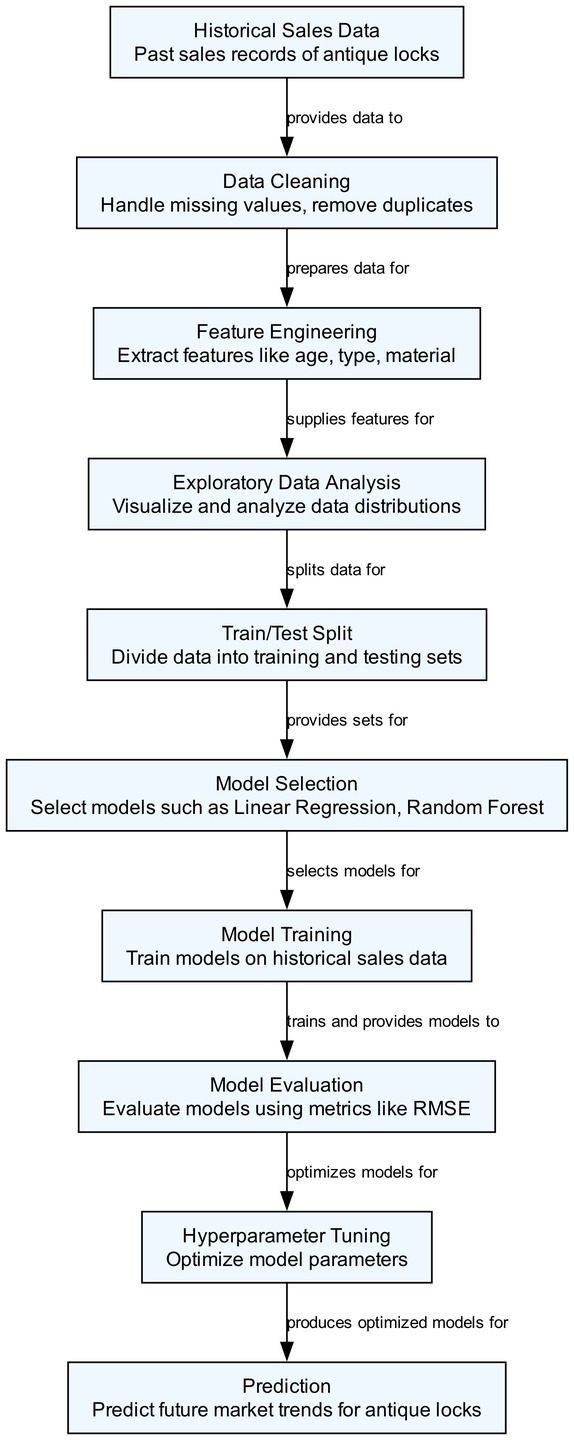What is the total number of nodes in the diagram? The diagram contains 10 nodes, which can be counted by listing each node represented in the diagram from the data provided.
Answer: 10 What does the node labeled "Historical Sales Data" provide data to? The "Historical Sales Data" node provides data to the "Data Cleaning" node, as indicated by the directed edge connecting them in the diagram.
Answer: Data Cleaning What follows after "Model Evaluation" in the process? After "Model Evaluation," the next step is "Hyperparameter Tuning," which is shown as a directed connection from the evaluation to the tuning in the diagram.
Answer: Hyperparameter Tuning Which node is responsible for extracting features? The node responsible for extracting features is "Feature Engineering," explicitly indicated in the diagram as supplying features for the "Exploratory Data Analysis" node.
Answer: Feature Engineering How many edges are in the diagram? The diagram contains 9 edges, which can be counted by assessing the connections shown between the nodes based on the edges list.
Answer: 9 What does "Data Cleaning" prepare data for? "Data Cleaning" prepares data for "Feature Engineering," as the diagram illustrates a connection indicating that cleaned data is necessary for feature extraction.
Answer: Feature Engineering What is the final output of the prediction process? The final output of the prediction process is the node labeled "Prediction," which is derived from the optimized models resulting from the earlier nodes in the diagram.
Answer: Prediction Which model types can be selected according to the diagram? The selected model types can be Linear Regression and Random Forest, as stated in the "Model Selection" node description within the diagram.
Answer: Linear Regression, Random Forest What does "Train/Test Split" provide sets for? "Train/Test Split" provides sets for "Model Selection," indicating that after splitting, the data is used to choose the appropriate models for training.
Answer: Model Selection What is the first step in the predictive modeling process? The first step in the predictive modeling process is "Historical Sales Data," as it provides the foundational data required for all subsequent steps in the diagram.
Answer: Historical Sales Data 